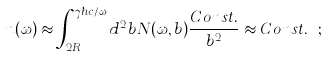Convert formula to latex. <formula><loc_0><loc_0><loc_500><loc_500>n ( \omega ) \approx \int _ { 2 R _ { A } } ^ { \gamma \hbar { c } / \omega } d ^ { 2 } b N ( \omega , b ) \frac { C o n s t . } { b ^ { 2 } } \approx C o n s t . \ ;</formula> 